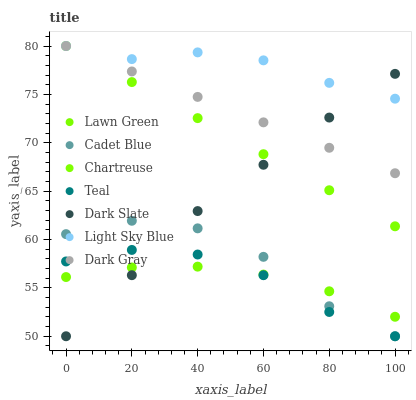Does Lawn Green have the minimum area under the curve?
Answer yes or no. Yes. Does Light Sky Blue have the maximum area under the curve?
Answer yes or no. Yes. Does Cadet Blue have the minimum area under the curve?
Answer yes or no. No. Does Cadet Blue have the maximum area under the curve?
Answer yes or no. No. Is Chartreuse the smoothest?
Answer yes or no. Yes. Is Cadet Blue the roughest?
Answer yes or no. Yes. Is Dark Gray the smoothest?
Answer yes or no. No. Is Dark Gray the roughest?
Answer yes or no. No. Does Cadet Blue have the lowest value?
Answer yes or no. Yes. Does Dark Gray have the lowest value?
Answer yes or no. No. Does Light Sky Blue have the highest value?
Answer yes or no. Yes. Does Cadet Blue have the highest value?
Answer yes or no. No. Is Cadet Blue less than Chartreuse?
Answer yes or no. Yes. Is Dark Gray greater than Lawn Green?
Answer yes or no. Yes. Does Dark Slate intersect Teal?
Answer yes or no. Yes. Is Dark Slate less than Teal?
Answer yes or no. No. Is Dark Slate greater than Teal?
Answer yes or no. No. Does Cadet Blue intersect Chartreuse?
Answer yes or no. No. 